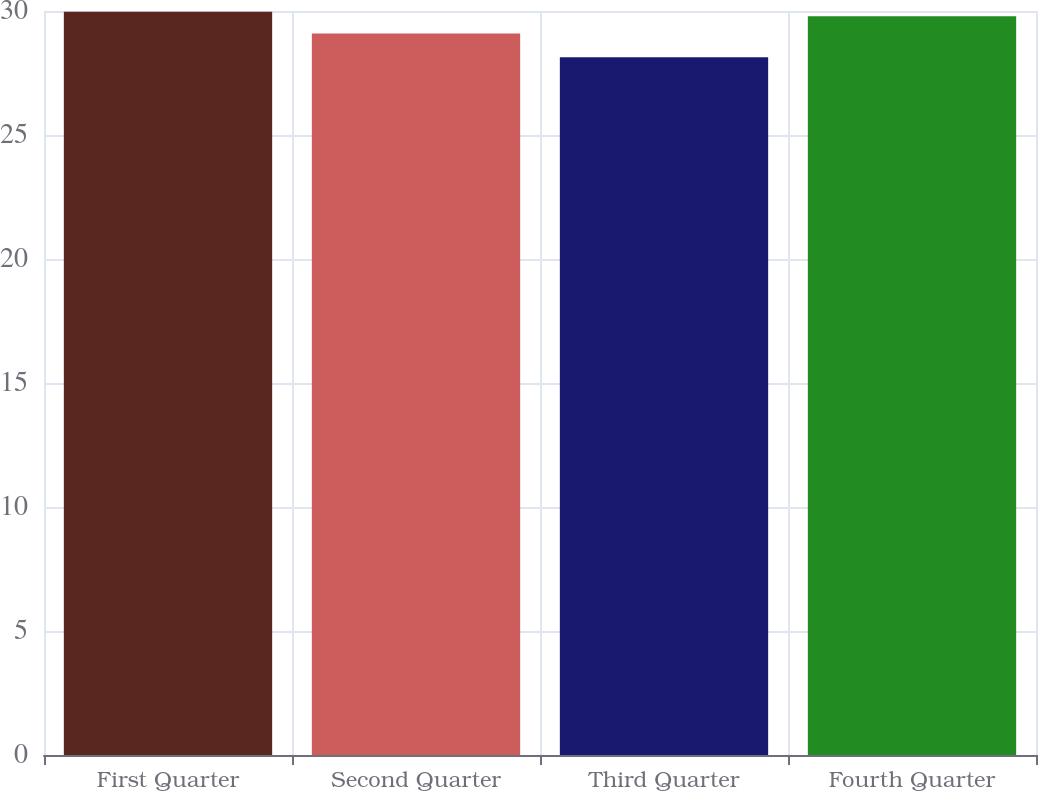Convert chart to OTSL. <chart><loc_0><loc_0><loc_500><loc_500><bar_chart><fcel>First Quarter<fcel>Second Quarter<fcel>Third Quarter<fcel>Fourth Quarter<nl><fcel>29.97<fcel>29.09<fcel>28.14<fcel>29.79<nl></chart> 